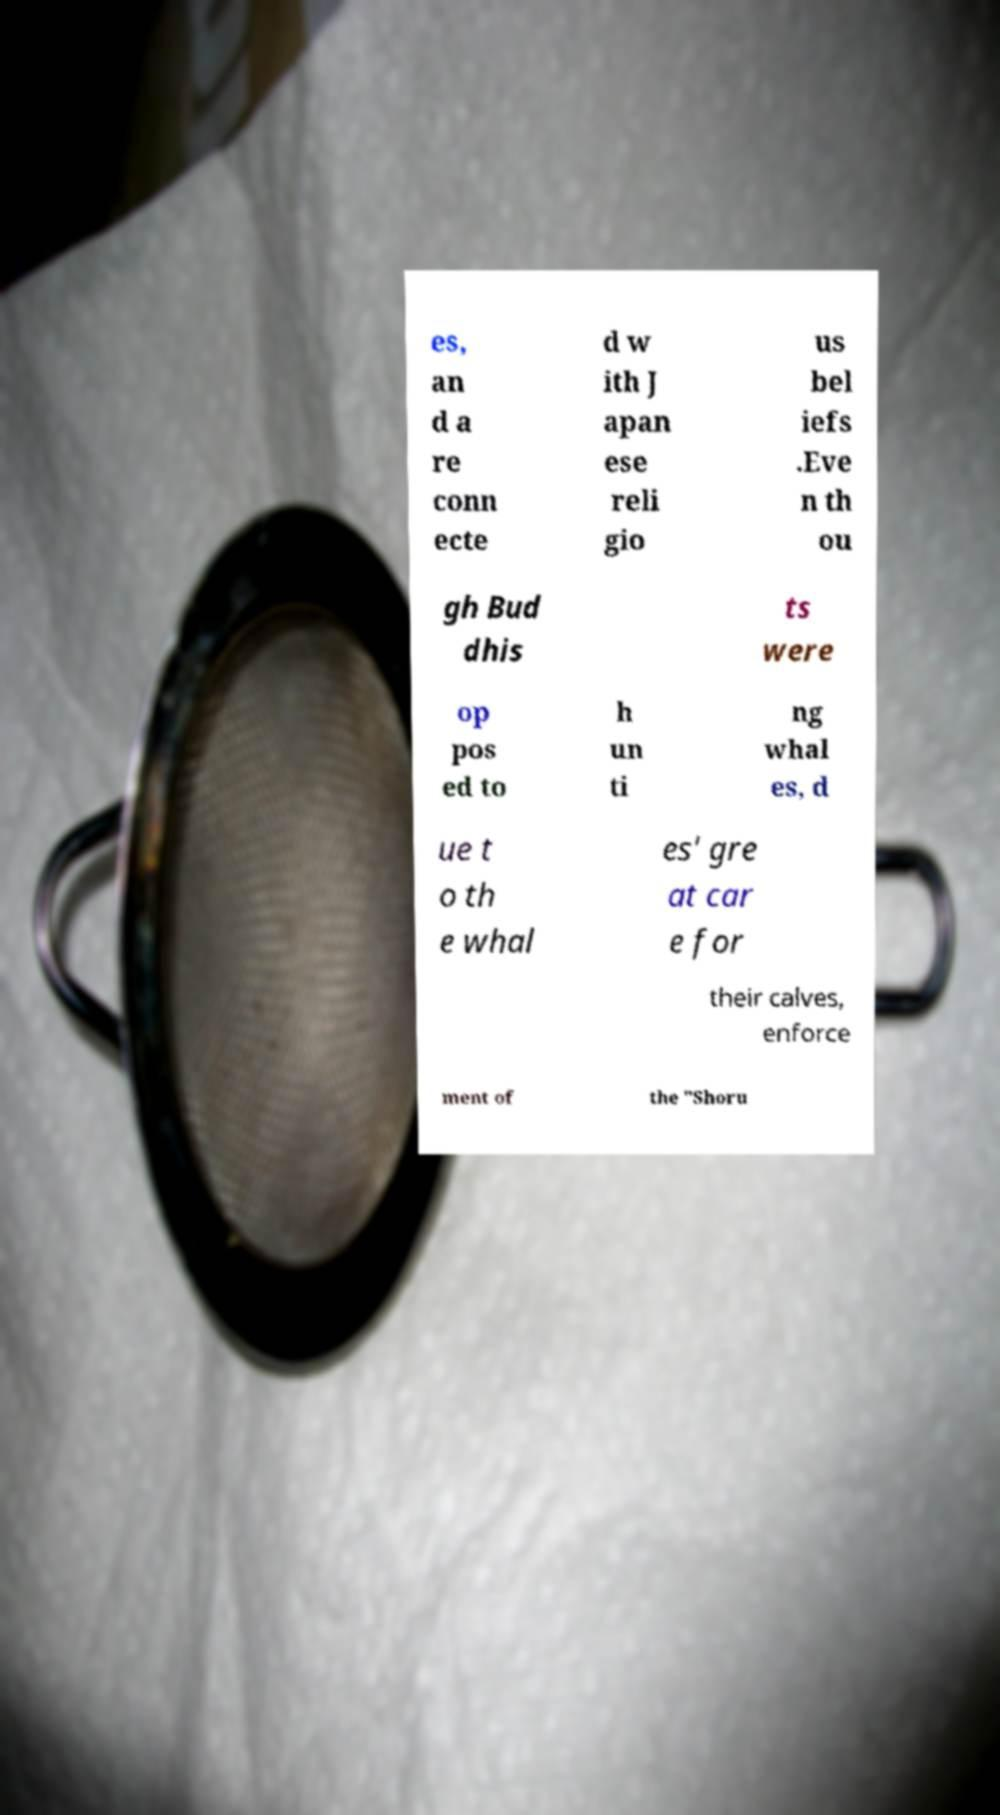Please read and relay the text visible in this image. What does it say? es, an d a re conn ecte d w ith J apan ese reli gio us bel iefs .Eve n th ou gh Bud dhis ts were op pos ed to h un ti ng whal es, d ue t o th e whal es' gre at car e for their calves, enforce ment of the "Shoru 